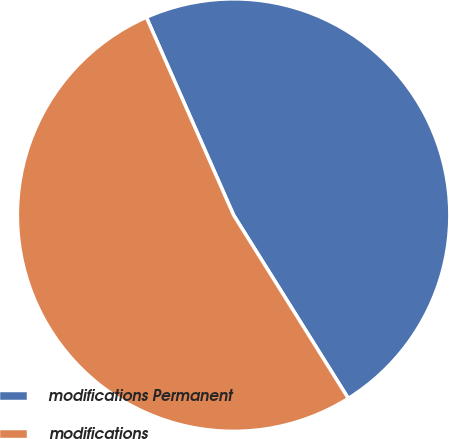Convert chart to OTSL. <chart><loc_0><loc_0><loc_500><loc_500><pie_chart><fcel>modifications Permanent<fcel>modifications<nl><fcel>47.71%<fcel>52.29%<nl></chart> 